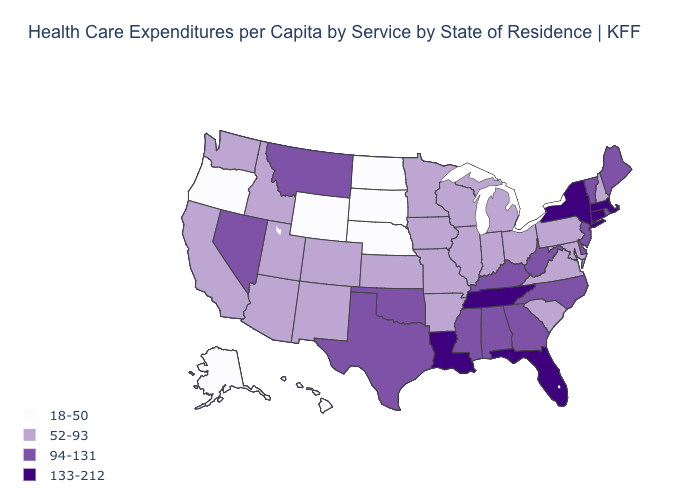Name the states that have a value in the range 94-131?
Give a very brief answer. Alabama, Delaware, Georgia, Kentucky, Maine, Mississippi, Montana, Nevada, New Jersey, North Carolina, Oklahoma, Rhode Island, Texas, Vermont, West Virginia. What is the value of Pennsylvania?
Short answer required. 52-93. Does the map have missing data?
Write a very short answer. No. Which states have the lowest value in the South?
Give a very brief answer. Arkansas, Maryland, South Carolina, Virginia. Name the states that have a value in the range 133-212?
Keep it brief. Connecticut, Florida, Louisiana, Massachusetts, New York, Tennessee. What is the lowest value in the West?
Give a very brief answer. 18-50. What is the value of Nebraska?
Be succinct. 18-50. Name the states that have a value in the range 133-212?
Quick response, please. Connecticut, Florida, Louisiana, Massachusetts, New York, Tennessee. Name the states that have a value in the range 133-212?
Write a very short answer. Connecticut, Florida, Louisiana, Massachusetts, New York, Tennessee. What is the lowest value in the South?
Answer briefly. 52-93. Which states have the lowest value in the USA?
Answer briefly. Alaska, Hawaii, Nebraska, North Dakota, Oregon, South Dakota, Wyoming. What is the lowest value in states that border Oklahoma?
Quick response, please. 52-93. Does Rhode Island have a lower value than Tennessee?
Short answer required. Yes. Name the states that have a value in the range 94-131?
Quick response, please. Alabama, Delaware, Georgia, Kentucky, Maine, Mississippi, Montana, Nevada, New Jersey, North Carolina, Oklahoma, Rhode Island, Texas, Vermont, West Virginia. Does Arkansas have a lower value than Florida?
Quick response, please. Yes. 